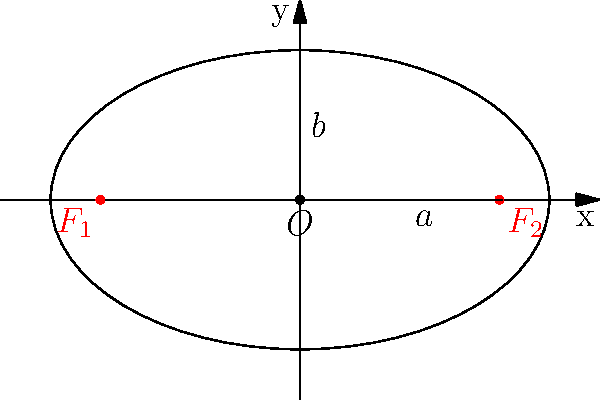In a microfinance study, the distribution of microcredit borrowers in a region is represented by an ellipse. The semi-major axis (a) is 5 units, and the semi-minor axis (b) is 3 units. Determine the coordinates of the focal points $F_1$ and $F_2$ of this ellipse. To find the focal points of an ellipse, we can follow these steps:

1) The equation for an ellipse centered at the origin is:
   $$\frac{x^2}{a^2} + \frac{y^2}{b^2} = 1$$

2) We are given that $a = 5$ and $b = 3$.

3) The focal points of an ellipse lie on its major axis. For an ellipse centered at the origin, the focal points are at $(±c, 0)$, where $c$ is the focal distance.

4) The focal distance $c$ is related to $a$ and $b$ by the equation:
   $$c^2 = a^2 - b^2$$

5) Substituting our values:
   $$c^2 = 5^2 - 3^2 = 25 - 9 = 16$$

6) Taking the square root:
   $$c = \sqrt{16} = 4$$

7) Therefore, the focal points are at:
   $F_1 = (-4, 0)$ and $F_2 = (4, 0)$

These coordinates represent the centers of microcredit activity in the region, which could be useful for planning outreach or assessing the geographical spread of borrowers.
Answer: $F_1 = (-4, 0)$ and $F_2 = (4, 0)$ 